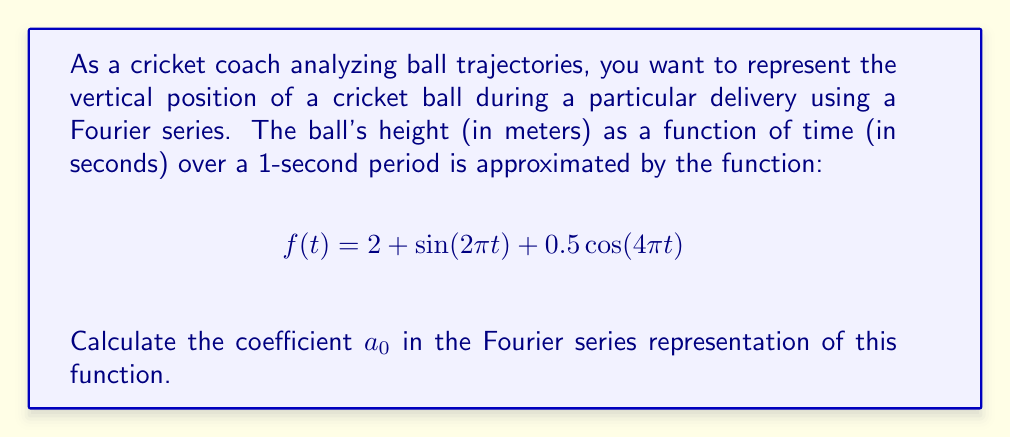Can you solve this math problem? To find the coefficient $a_0$ in the Fourier series representation, we need to calculate the average value of the function over one period. The general formula for $a_0$ is:

$$a_0 = \frac{1}{T}\int_{0}^{T} f(t) dt$$

where $T$ is the period of the function. In this case, $T = 1$ second.

Let's break down the calculation:

1) We need to integrate $f(t) = 2 + \sin(2\pi t) + 0.5\cos(4\pi t)$ from 0 to 1:

   $$a_0 = \int_{0}^{1} (2 + \sin(2\pi t) + 0.5\cos(4\pi t)) dt$$

2) We can integrate each term separately:

   $$a_0 = \int_{0}^{1} 2 dt + \int_{0}^{1} \sin(2\pi t) dt + \int_{0}^{1} 0.5\cos(4\pi t) dt$$

3) Evaluating each integral:
   
   - $\int_{0}^{1} 2 dt = 2t |_{0}^{1} = 2$
   
   - $\int_{0}^{1} \sin(2\pi t) dt = -\frac{1}{2\pi}\cos(2\pi t) |_{0}^{1} = 0$
   
   - $\int_{0}^{1} 0.5\cos(4\pi t) dt = 0.5 \cdot \frac{1}{4\pi}\sin(4\pi t) |_{0}^{1} = 0$

4) Adding these results:

   $$a_0 = 2 + 0 + 0 = 2$$

Therefore, the coefficient $a_0$ in the Fourier series representation of this function is 2.
Answer: $a_0 = 2$ 